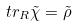<formula> <loc_0><loc_0><loc_500><loc_500>t r _ { R } \tilde { \chi } = \tilde { \rho }</formula> 